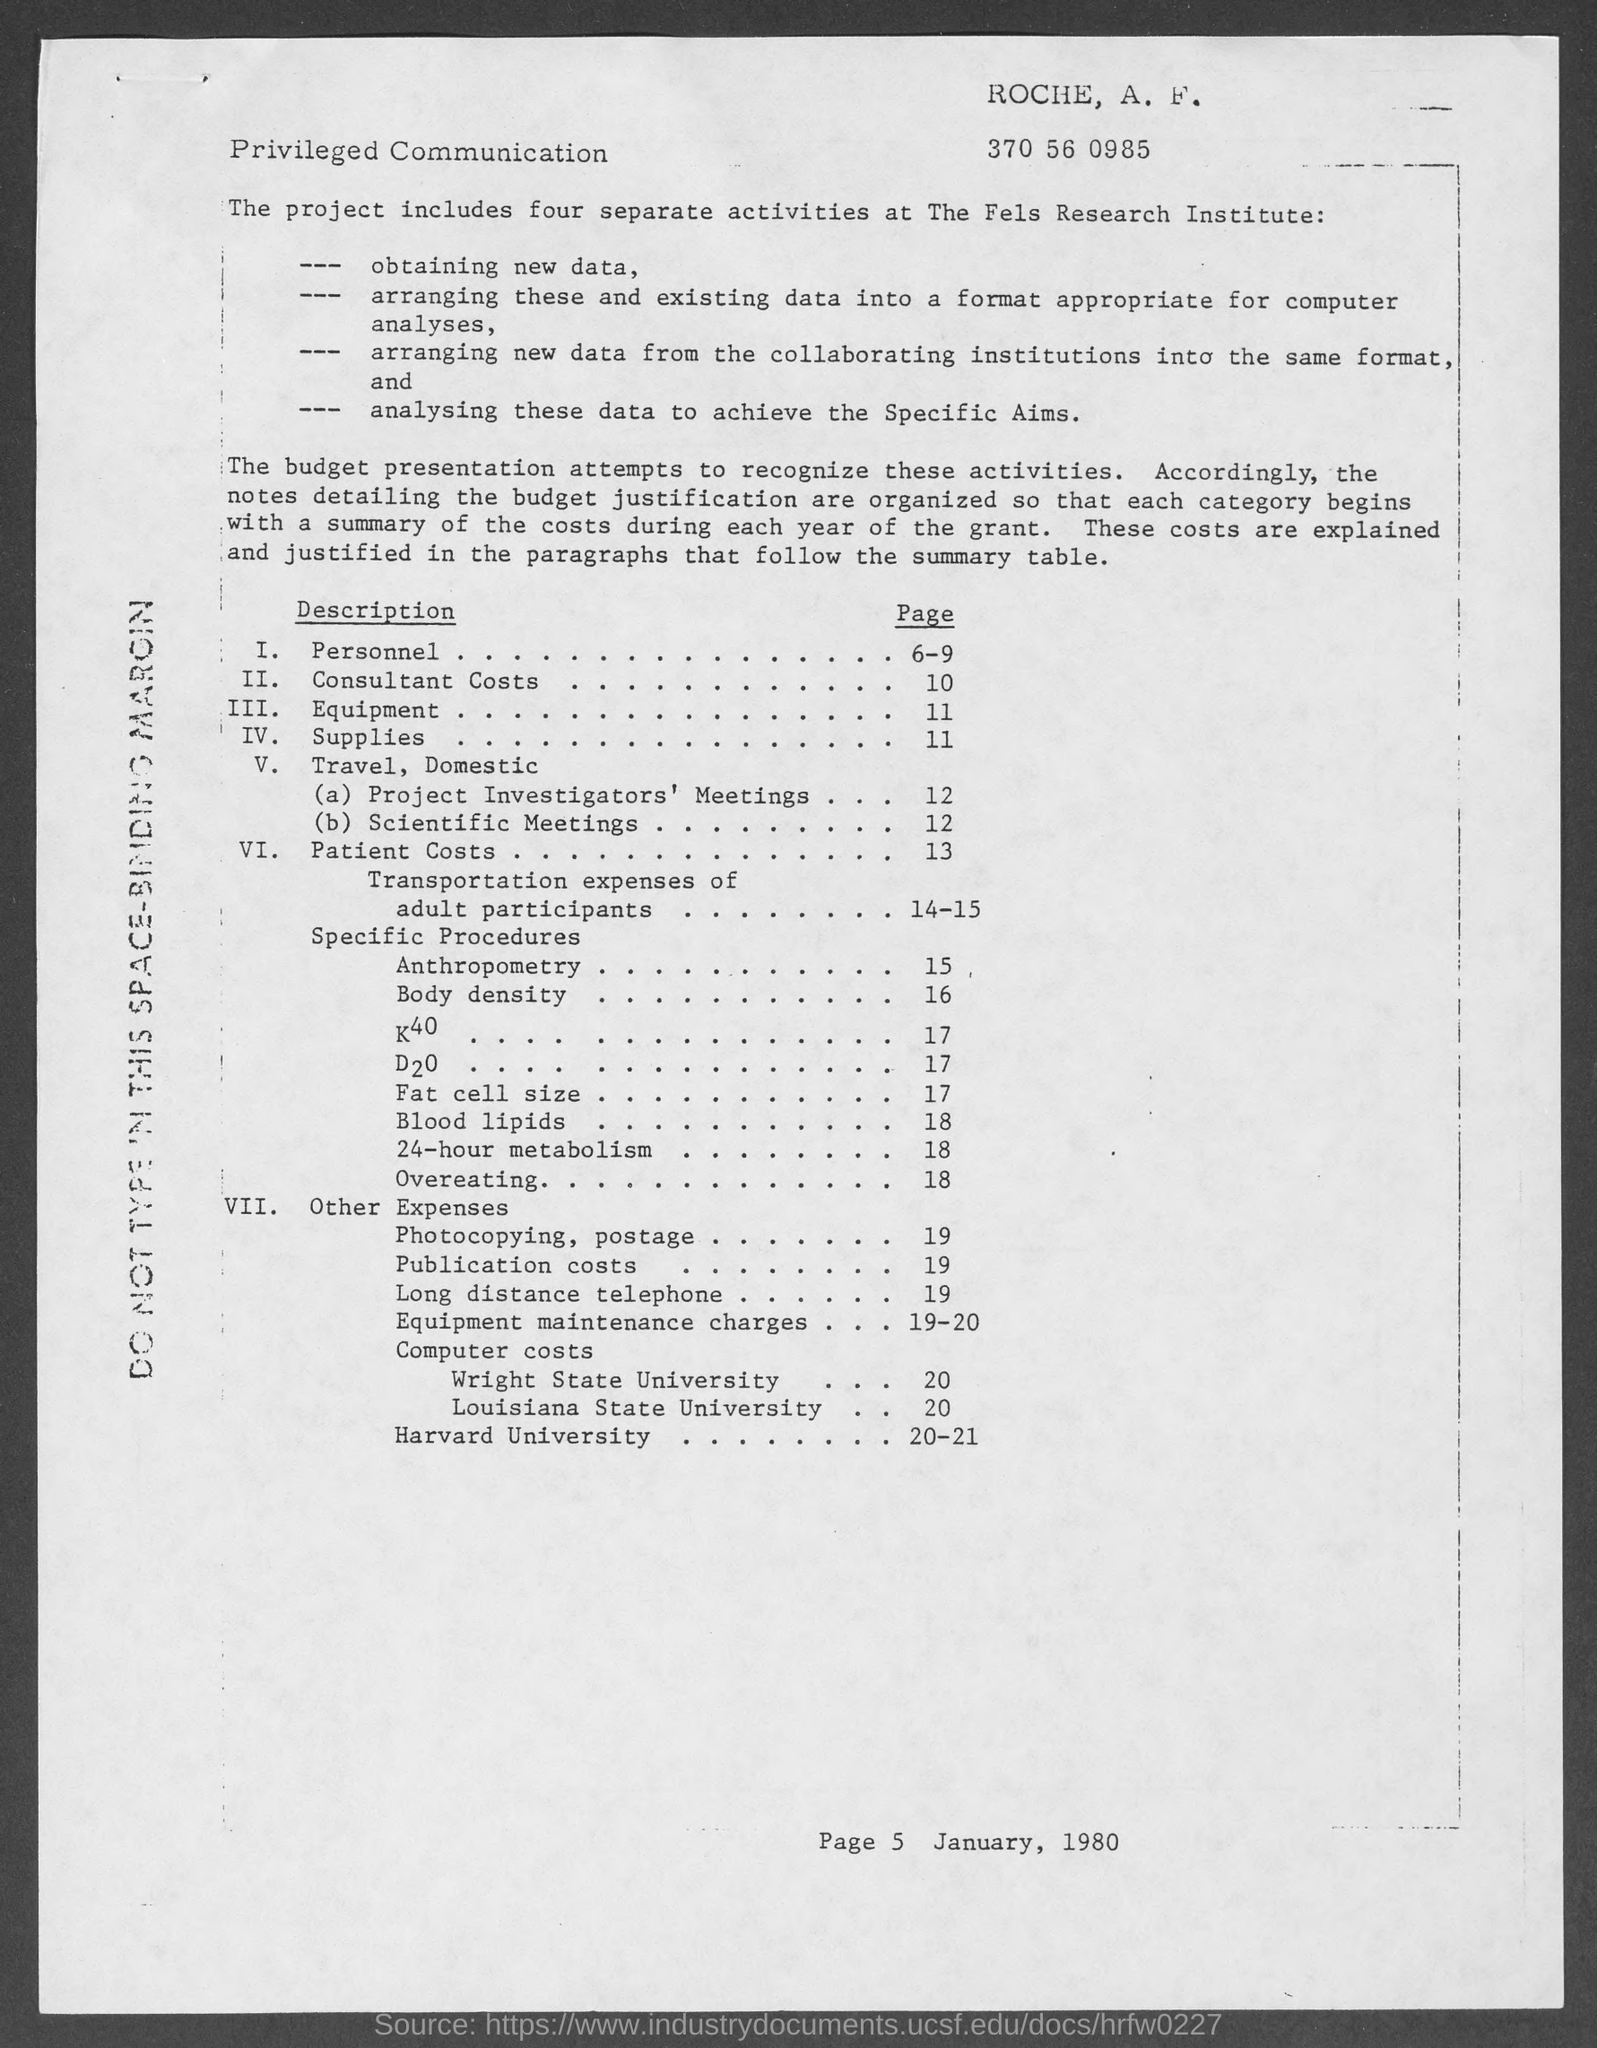Specify some key components in this picture. The page number where the word "personnel" appears is 6-9. On page 10, the term "consultant cost" can be found. I am not able to understand the input provided. Could you please provide more context or clarify your request? The location of scientific meetings is mentioned on page 12. 